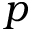<formula> <loc_0><loc_0><loc_500><loc_500>p</formula> 